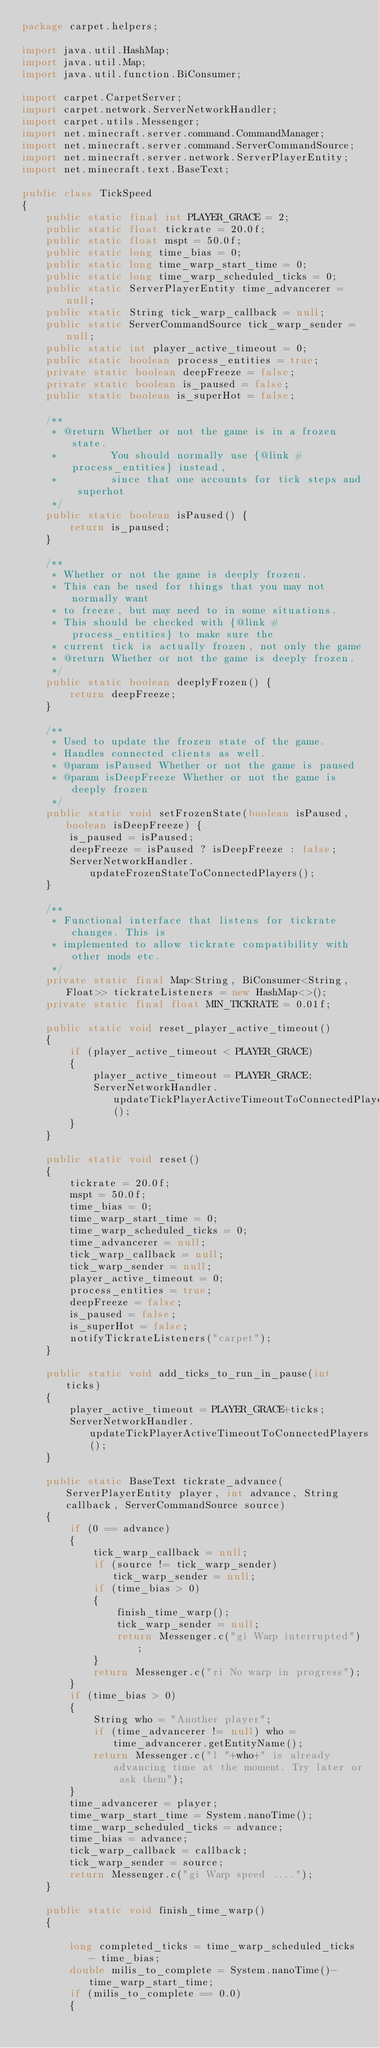Convert code to text. <code><loc_0><loc_0><loc_500><loc_500><_Java_>package carpet.helpers;

import java.util.HashMap;
import java.util.Map;
import java.util.function.BiConsumer;

import carpet.CarpetServer;
import carpet.network.ServerNetworkHandler;
import carpet.utils.Messenger;
import net.minecraft.server.command.CommandManager;
import net.minecraft.server.command.ServerCommandSource;
import net.minecraft.server.network.ServerPlayerEntity;
import net.minecraft.text.BaseText;

public class TickSpeed
{
    public static final int PLAYER_GRACE = 2;
    public static float tickrate = 20.0f;
    public static float mspt = 50.0f;
    public static long time_bias = 0;
    public static long time_warp_start_time = 0;
    public static long time_warp_scheduled_ticks = 0;
    public static ServerPlayerEntity time_advancerer = null;
    public static String tick_warp_callback = null;
    public static ServerCommandSource tick_warp_sender = null;
    public static int player_active_timeout = 0;
    public static boolean process_entities = true;
    private static boolean deepFreeze = false;
    private static boolean is_paused = false;
    public static boolean is_superHot = false;

    /**
     * @return Whether or not the game is in a frozen state.
     *         You should normally use {@link #process_entities} instead,
     *         since that one accounts for tick steps and superhot
     */
    public static boolean isPaused() {
	    return is_paused;
    }

    /**
     * Whether or not the game is deeply frozen.
     * This can be used for things that you may not normally want
     * to freeze, but may need to in some situations.
     * This should be checked with {@link #process_entities} to make sure the 
     * current tick is actually frozen, not only the game
     * @return Whether or not the game is deeply frozen.
     */
    public static boolean deeplyFrozen() {
        return deepFreeze;
    }

    /**
     * Used to update the frozen state of the game.
     * Handles connected clients as well.
     * @param isPaused Whether or not the game is paused
     * @param isDeepFreeze Whether or not the game is deeply frozen
     */
    public static void setFrozenState(boolean isPaused, boolean isDeepFreeze) {
        is_paused = isPaused;
        deepFreeze = isPaused ? isDeepFreeze : false;
        ServerNetworkHandler.updateFrozenStateToConnectedPlayers();
    }

    /**
     * Functional interface that listens for tickrate changes. This is
     * implemented to allow tickrate compatibility with other mods etc.
     */
    private static final Map<String, BiConsumer<String, Float>> tickrateListeners = new HashMap<>();
    private static final float MIN_TICKRATE = 0.01f;
    
    public static void reset_player_active_timeout()
    {
        if (player_active_timeout < PLAYER_GRACE)
        {
            player_active_timeout = PLAYER_GRACE;
            ServerNetworkHandler.updateTickPlayerActiveTimeoutToConnectedPlayers();
        }
    }

    public static void reset()
    {
        tickrate = 20.0f;
        mspt = 50.0f;
        time_bias = 0;
        time_warp_start_time = 0;
        time_warp_scheduled_ticks = 0;
        time_advancerer = null;
        tick_warp_callback = null;
        tick_warp_sender = null;
        player_active_timeout = 0;
        process_entities = true;
        deepFreeze = false;
        is_paused = false;
        is_superHot = false;
        notifyTickrateListeners("carpet");
    }

    public static void add_ticks_to_run_in_pause(int ticks)
    {
        player_active_timeout = PLAYER_GRACE+ticks;
        ServerNetworkHandler.updateTickPlayerActiveTimeoutToConnectedPlayers();
    }

    public static BaseText tickrate_advance(ServerPlayerEntity player, int advance, String callback, ServerCommandSource source)
    {
        if (0 == advance)
        {
            tick_warp_callback = null;
            if (source != tick_warp_sender) tick_warp_sender = null;
            if (time_bias > 0)
            {
                finish_time_warp();
                tick_warp_sender = null;
                return Messenger.c("gi Warp interrupted");
            }
            return Messenger.c("ri No warp in progress");
        }
        if (time_bias > 0)
        {
            String who = "Another player";
            if (time_advancerer != null) who = time_advancerer.getEntityName();
            return Messenger.c("l "+who+" is already advancing time at the moment. Try later or ask them");
        }
        time_advancerer = player;
        time_warp_start_time = System.nanoTime();
        time_warp_scheduled_ticks = advance;
        time_bias = advance;
        tick_warp_callback = callback;
        tick_warp_sender = source;
        return Messenger.c("gi Warp speed ....");
    }

    public static void finish_time_warp()
    {

        long completed_ticks = time_warp_scheduled_ticks - time_bias;
        double milis_to_complete = System.nanoTime()-time_warp_start_time;
        if (milis_to_complete == 0.0)
        {</code> 